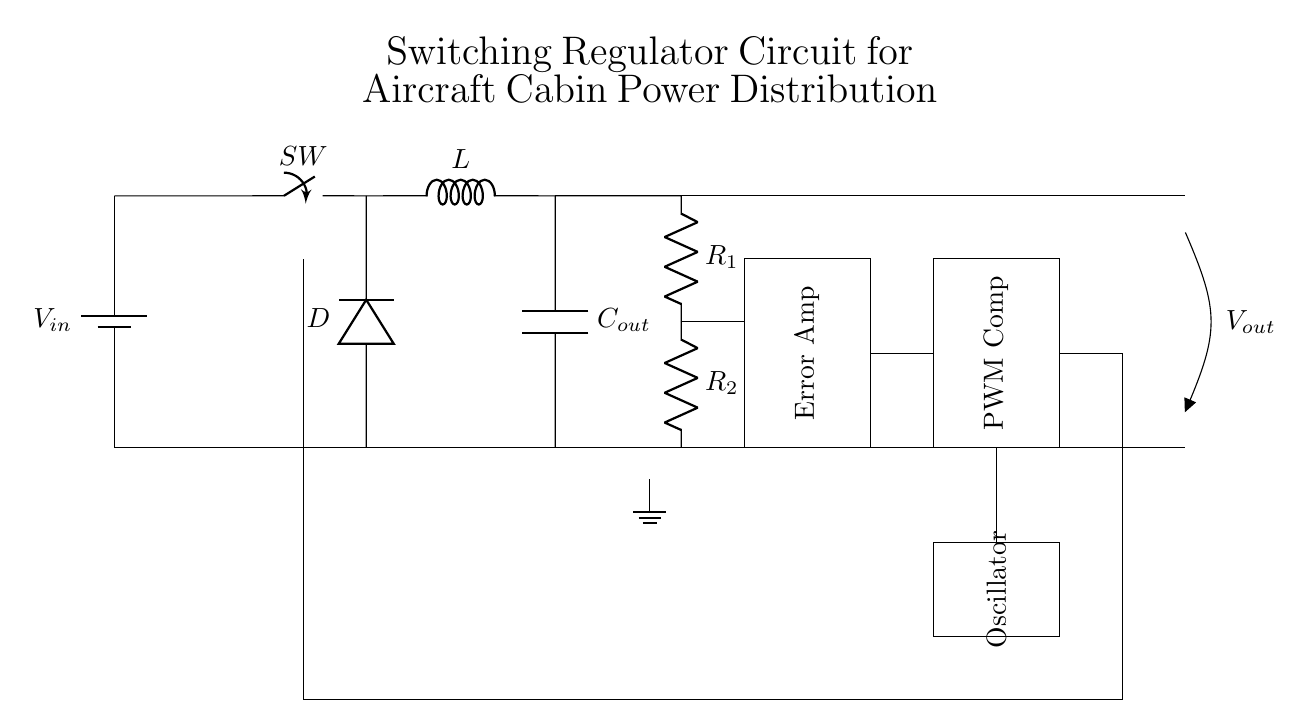What is the input component of the circuit? The input component is a battery, which is indicated by the label "V_in" that represents the voltage source supplying power to the circuit.
Answer: Battery What is the output voltage designation in the circuit? The output voltage is labeled "V_out" in the circuit diagram, indicating the voltage delivered to the load or connected devices.
Answer: V_out What type of switch is used in this circuit? The circuit uses a closing switch, as indicated by the label "SW," which allows control over the connection in the circuit.
Answer: Closing switch What is the role of the inductor labeled as "L"? The inductor, labeled "L," stores energy when current flows through it and also contributes to smoothing the output voltage in a switching regulator circuit.
Answer: Energy storage How does the feedback loop affect the regulation of output voltage? The feedback loop compares the output voltage with a reference voltage within the error amplifier, adjusting the PWM signal accordingly to maintain a constant output voltage despite variations in input voltage or load.
Answer: Maintains constant output voltage What is the function of the diode labeled "D" in this circuit? The diode allows current to flow in one direction only, thereby preventing backflow and protecting components by ensuring that the inductor discharges energy only to the output capacitor when the switch is open.
Answer: Prevents backflow Which component ensures pulse-width modulation in the circuit? The PWM comparator is responsible for comparing the feedback voltage and controlling the switch to modulate the pulse width, thus regulating the output voltage.
Answer: PWM Comparator 